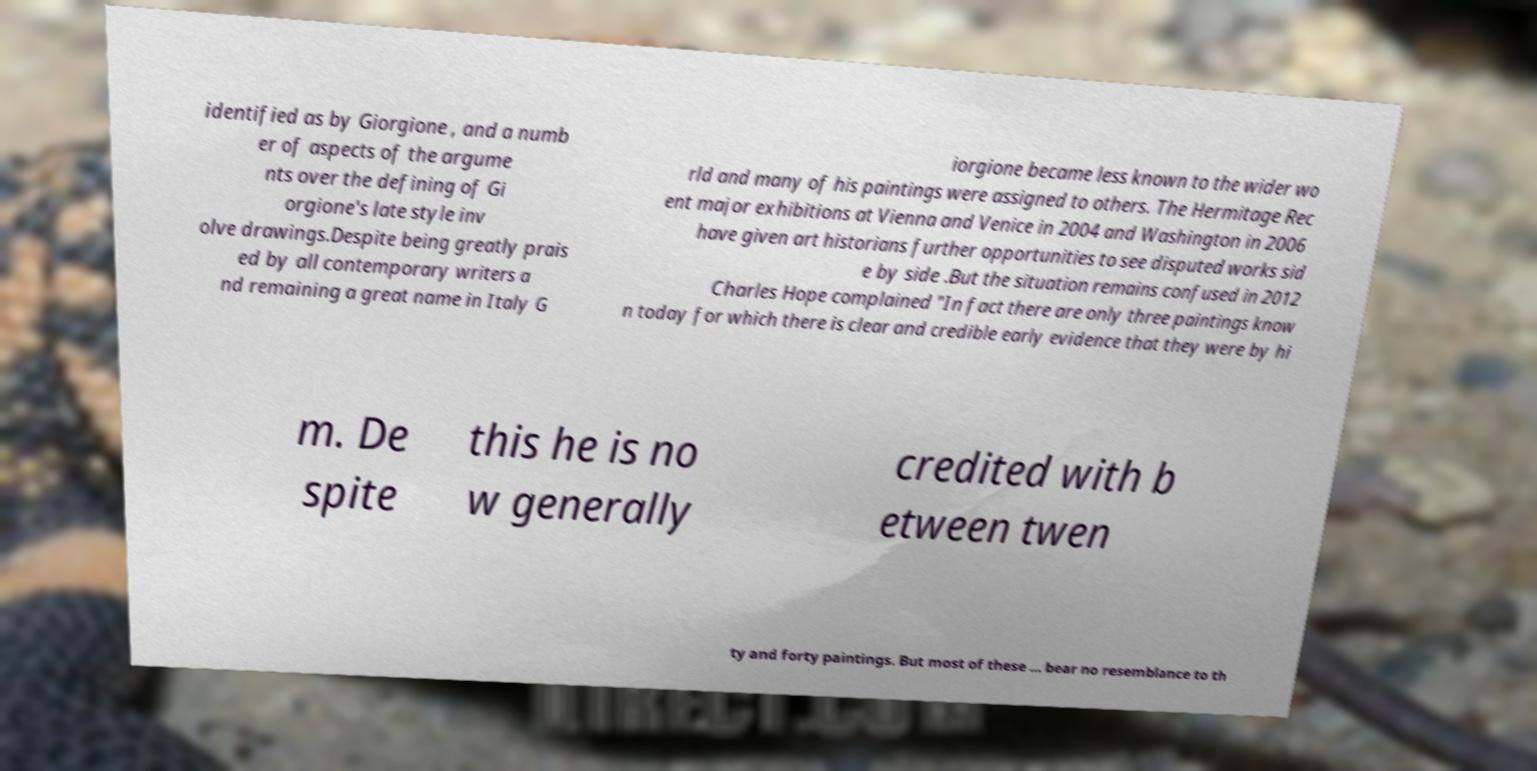Can you read and provide the text displayed in the image?This photo seems to have some interesting text. Can you extract and type it out for me? identified as by Giorgione , and a numb er of aspects of the argume nts over the defining of Gi orgione's late style inv olve drawings.Despite being greatly prais ed by all contemporary writers a nd remaining a great name in Italy G iorgione became less known to the wider wo rld and many of his paintings were assigned to others. The Hermitage Rec ent major exhibitions at Vienna and Venice in 2004 and Washington in 2006 have given art historians further opportunities to see disputed works sid e by side .But the situation remains confused in 2012 Charles Hope complained "In fact there are only three paintings know n today for which there is clear and credible early evidence that they were by hi m. De spite this he is no w generally credited with b etween twen ty and forty paintings. But most of these ... bear no resemblance to th 